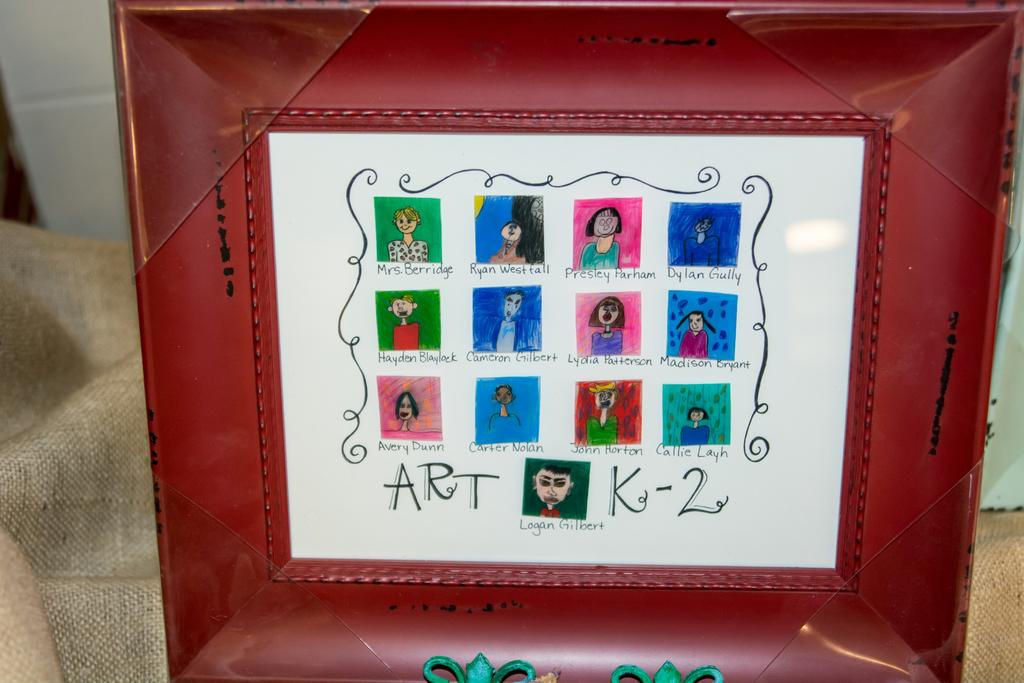What object can be seen in the image? There is a photo frame in the image. How does the wind affect the photo frame in the image? There is no wind present in the image, and therefore no effect on the photo frame can be observed. 